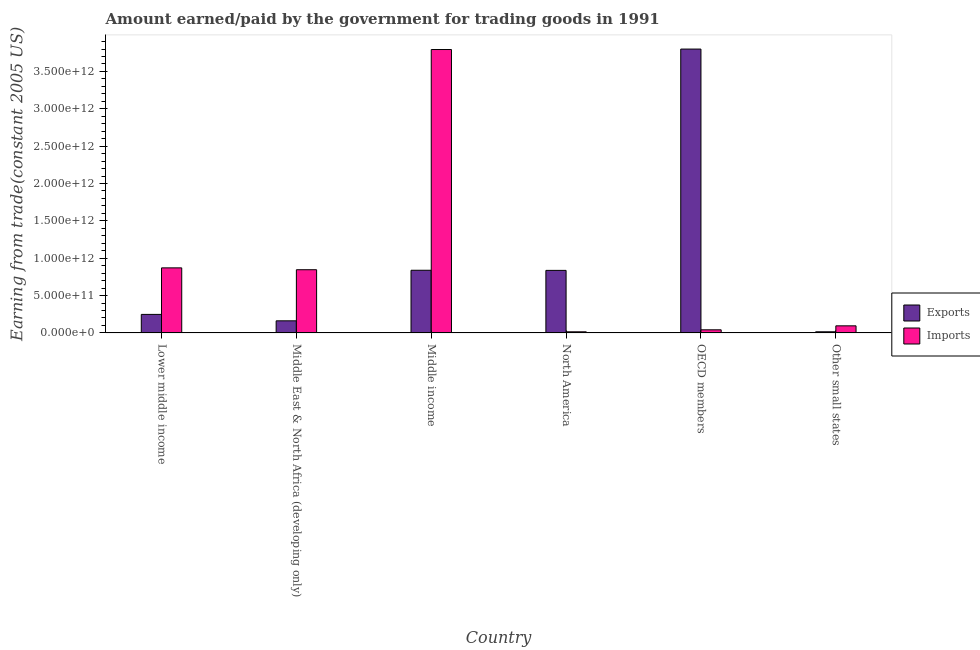How many different coloured bars are there?
Give a very brief answer. 2. Are the number of bars per tick equal to the number of legend labels?
Ensure brevity in your answer.  Yes. Are the number of bars on each tick of the X-axis equal?
Ensure brevity in your answer.  Yes. How many bars are there on the 6th tick from the right?
Offer a very short reply. 2. What is the label of the 1st group of bars from the left?
Ensure brevity in your answer.  Lower middle income. What is the amount earned from exports in Middle income?
Offer a very short reply. 8.39e+11. Across all countries, what is the maximum amount paid for imports?
Offer a very short reply. 3.79e+12. Across all countries, what is the minimum amount earned from exports?
Your answer should be compact. 1.55e+1. In which country was the amount earned from exports minimum?
Ensure brevity in your answer.  Other small states. What is the total amount earned from exports in the graph?
Offer a very short reply. 5.90e+12. What is the difference between the amount paid for imports in Middle East & North Africa (developing only) and that in Middle income?
Offer a terse response. -2.95e+12. What is the difference between the amount paid for imports in Lower middle income and the amount earned from exports in North America?
Ensure brevity in your answer.  3.37e+1. What is the average amount paid for imports per country?
Your answer should be very brief. 9.44e+11. What is the difference between the amount paid for imports and amount earned from exports in Middle East & North Africa (developing only)?
Your response must be concise. 6.84e+11. In how many countries, is the amount earned from exports greater than 2000000000000 US$?
Provide a succinct answer. 1. What is the ratio of the amount earned from exports in Lower middle income to that in Middle East & North Africa (developing only)?
Offer a terse response. 1.53. Is the amount paid for imports in OECD members less than that in Other small states?
Make the answer very short. Yes. Is the difference between the amount paid for imports in Middle East & North Africa (developing only) and OECD members greater than the difference between the amount earned from exports in Middle East & North Africa (developing only) and OECD members?
Your answer should be very brief. Yes. What is the difference between the highest and the second highest amount earned from exports?
Provide a short and direct response. 2.96e+12. What is the difference between the highest and the lowest amount earned from exports?
Your answer should be very brief. 3.78e+12. Is the sum of the amount paid for imports in North America and Other small states greater than the maximum amount earned from exports across all countries?
Your response must be concise. No. What does the 1st bar from the left in Middle East & North Africa (developing only) represents?
Give a very brief answer. Exports. What does the 1st bar from the right in Lower middle income represents?
Give a very brief answer. Imports. Are all the bars in the graph horizontal?
Give a very brief answer. No. What is the difference between two consecutive major ticks on the Y-axis?
Provide a succinct answer. 5.00e+11. Does the graph contain grids?
Provide a short and direct response. No. Where does the legend appear in the graph?
Provide a succinct answer. Center right. How are the legend labels stacked?
Offer a terse response. Vertical. What is the title of the graph?
Keep it short and to the point. Amount earned/paid by the government for trading goods in 1991. Does "Lower secondary rate" appear as one of the legend labels in the graph?
Give a very brief answer. No. What is the label or title of the Y-axis?
Keep it short and to the point. Earning from trade(constant 2005 US). What is the Earning from trade(constant 2005 US) of Exports in Lower middle income?
Offer a terse response. 2.48e+11. What is the Earning from trade(constant 2005 US) in Imports in Lower middle income?
Your answer should be very brief. 8.71e+11. What is the Earning from trade(constant 2005 US) of Exports in Middle East & North Africa (developing only)?
Your response must be concise. 1.62e+11. What is the Earning from trade(constant 2005 US) of Imports in Middle East & North Africa (developing only)?
Provide a succinct answer. 8.46e+11. What is the Earning from trade(constant 2005 US) of Exports in Middle income?
Offer a terse response. 8.39e+11. What is the Earning from trade(constant 2005 US) of Imports in Middle income?
Your answer should be compact. 3.79e+12. What is the Earning from trade(constant 2005 US) of Exports in North America?
Provide a succinct answer. 8.37e+11. What is the Earning from trade(constant 2005 US) in Imports in North America?
Offer a terse response. 1.52e+1. What is the Earning from trade(constant 2005 US) of Exports in OECD members?
Your response must be concise. 3.80e+12. What is the Earning from trade(constant 2005 US) of Imports in OECD members?
Your answer should be compact. 4.19e+1. What is the Earning from trade(constant 2005 US) in Exports in Other small states?
Provide a succinct answer. 1.55e+1. What is the Earning from trade(constant 2005 US) of Imports in Other small states?
Provide a succinct answer. 9.51e+1. Across all countries, what is the maximum Earning from trade(constant 2005 US) of Exports?
Make the answer very short. 3.80e+12. Across all countries, what is the maximum Earning from trade(constant 2005 US) in Imports?
Give a very brief answer. 3.79e+12. Across all countries, what is the minimum Earning from trade(constant 2005 US) in Exports?
Provide a succinct answer. 1.55e+1. Across all countries, what is the minimum Earning from trade(constant 2005 US) of Imports?
Your response must be concise. 1.52e+1. What is the total Earning from trade(constant 2005 US) in Exports in the graph?
Provide a succinct answer. 5.90e+12. What is the total Earning from trade(constant 2005 US) in Imports in the graph?
Provide a succinct answer. 5.66e+12. What is the difference between the Earning from trade(constant 2005 US) of Exports in Lower middle income and that in Middle East & North Africa (developing only)?
Ensure brevity in your answer.  8.59e+1. What is the difference between the Earning from trade(constant 2005 US) of Imports in Lower middle income and that in Middle East & North Africa (developing only)?
Offer a terse response. 2.50e+1. What is the difference between the Earning from trade(constant 2005 US) in Exports in Lower middle income and that in Middle income?
Your response must be concise. -5.91e+11. What is the difference between the Earning from trade(constant 2005 US) in Imports in Lower middle income and that in Middle income?
Provide a short and direct response. -2.92e+12. What is the difference between the Earning from trade(constant 2005 US) in Exports in Lower middle income and that in North America?
Offer a very short reply. -5.89e+11. What is the difference between the Earning from trade(constant 2005 US) in Imports in Lower middle income and that in North America?
Make the answer very short. 8.56e+11. What is the difference between the Earning from trade(constant 2005 US) of Exports in Lower middle income and that in OECD members?
Make the answer very short. -3.55e+12. What is the difference between the Earning from trade(constant 2005 US) in Imports in Lower middle income and that in OECD members?
Provide a succinct answer. 8.29e+11. What is the difference between the Earning from trade(constant 2005 US) of Exports in Lower middle income and that in Other small states?
Offer a very short reply. 2.33e+11. What is the difference between the Earning from trade(constant 2005 US) of Imports in Lower middle income and that in Other small states?
Make the answer very short. 7.76e+11. What is the difference between the Earning from trade(constant 2005 US) in Exports in Middle East & North Africa (developing only) and that in Middle income?
Provide a succinct answer. -6.77e+11. What is the difference between the Earning from trade(constant 2005 US) of Imports in Middle East & North Africa (developing only) and that in Middle income?
Offer a very short reply. -2.95e+12. What is the difference between the Earning from trade(constant 2005 US) of Exports in Middle East & North Africa (developing only) and that in North America?
Give a very brief answer. -6.75e+11. What is the difference between the Earning from trade(constant 2005 US) in Imports in Middle East & North Africa (developing only) and that in North America?
Offer a terse response. 8.31e+11. What is the difference between the Earning from trade(constant 2005 US) in Exports in Middle East & North Africa (developing only) and that in OECD members?
Offer a terse response. -3.64e+12. What is the difference between the Earning from trade(constant 2005 US) in Imports in Middle East & North Africa (developing only) and that in OECD members?
Your answer should be compact. 8.04e+11. What is the difference between the Earning from trade(constant 2005 US) in Exports in Middle East & North Africa (developing only) and that in Other small states?
Provide a short and direct response. 1.47e+11. What is the difference between the Earning from trade(constant 2005 US) of Imports in Middle East & North Africa (developing only) and that in Other small states?
Your answer should be very brief. 7.51e+11. What is the difference between the Earning from trade(constant 2005 US) in Exports in Middle income and that in North America?
Your answer should be compact. 1.74e+09. What is the difference between the Earning from trade(constant 2005 US) in Imports in Middle income and that in North America?
Offer a terse response. 3.78e+12. What is the difference between the Earning from trade(constant 2005 US) of Exports in Middle income and that in OECD members?
Provide a short and direct response. -2.96e+12. What is the difference between the Earning from trade(constant 2005 US) in Imports in Middle income and that in OECD members?
Ensure brevity in your answer.  3.75e+12. What is the difference between the Earning from trade(constant 2005 US) in Exports in Middle income and that in Other small states?
Keep it short and to the point. 8.24e+11. What is the difference between the Earning from trade(constant 2005 US) of Imports in Middle income and that in Other small states?
Provide a succinct answer. 3.70e+12. What is the difference between the Earning from trade(constant 2005 US) in Exports in North America and that in OECD members?
Your response must be concise. -2.96e+12. What is the difference between the Earning from trade(constant 2005 US) in Imports in North America and that in OECD members?
Keep it short and to the point. -2.67e+1. What is the difference between the Earning from trade(constant 2005 US) in Exports in North America and that in Other small states?
Your answer should be very brief. 8.22e+11. What is the difference between the Earning from trade(constant 2005 US) of Imports in North America and that in Other small states?
Give a very brief answer. -7.99e+1. What is the difference between the Earning from trade(constant 2005 US) in Exports in OECD members and that in Other small states?
Give a very brief answer. 3.78e+12. What is the difference between the Earning from trade(constant 2005 US) of Imports in OECD members and that in Other small states?
Keep it short and to the point. -5.32e+1. What is the difference between the Earning from trade(constant 2005 US) of Exports in Lower middle income and the Earning from trade(constant 2005 US) of Imports in Middle East & North Africa (developing only)?
Provide a succinct answer. -5.98e+11. What is the difference between the Earning from trade(constant 2005 US) in Exports in Lower middle income and the Earning from trade(constant 2005 US) in Imports in Middle income?
Provide a short and direct response. -3.55e+12. What is the difference between the Earning from trade(constant 2005 US) in Exports in Lower middle income and the Earning from trade(constant 2005 US) in Imports in North America?
Provide a succinct answer. 2.33e+11. What is the difference between the Earning from trade(constant 2005 US) in Exports in Lower middle income and the Earning from trade(constant 2005 US) in Imports in OECD members?
Your answer should be very brief. 2.06e+11. What is the difference between the Earning from trade(constant 2005 US) in Exports in Lower middle income and the Earning from trade(constant 2005 US) in Imports in Other small states?
Provide a short and direct response. 1.53e+11. What is the difference between the Earning from trade(constant 2005 US) in Exports in Middle East & North Africa (developing only) and the Earning from trade(constant 2005 US) in Imports in Middle income?
Make the answer very short. -3.63e+12. What is the difference between the Earning from trade(constant 2005 US) of Exports in Middle East & North Africa (developing only) and the Earning from trade(constant 2005 US) of Imports in North America?
Your answer should be very brief. 1.47e+11. What is the difference between the Earning from trade(constant 2005 US) in Exports in Middle East & North Africa (developing only) and the Earning from trade(constant 2005 US) in Imports in OECD members?
Offer a very short reply. 1.20e+11. What is the difference between the Earning from trade(constant 2005 US) in Exports in Middle East & North Africa (developing only) and the Earning from trade(constant 2005 US) in Imports in Other small states?
Provide a succinct answer. 6.71e+1. What is the difference between the Earning from trade(constant 2005 US) of Exports in Middle income and the Earning from trade(constant 2005 US) of Imports in North America?
Provide a short and direct response. 8.24e+11. What is the difference between the Earning from trade(constant 2005 US) of Exports in Middle income and the Earning from trade(constant 2005 US) of Imports in OECD members?
Make the answer very short. 7.97e+11. What is the difference between the Earning from trade(constant 2005 US) in Exports in Middle income and the Earning from trade(constant 2005 US) in Imports in Other small states?
Provide a succinct answer. 7.44e+11. What is the difference between the Earning from trade(constant 2005 US) in Exports in North America and the Earning from trade(constant 2005 US) in Imports in OECD members?
Give a very brief answer. 7.95e+11. What is the difference between the Earning from trade(constant 2005 US) of Exports in North America and the Earning from trade(constant 2005 US) of Imports in Other small states?
Make the answer very short. 7.42e+11. What is the difference between the Earning from trade(constant 2005 US) of Exports in OECD members and the Earning from trade(constant 2005 US) of Imports in Other small states?
Provide a short and direct response. 3.70e+12. What is the average Earning from trade(constant 2005 US) of Exports per country?
Your answer should be very brief. 9.84e+11. What is the average Earning from trade(constant 2005 US) in Imports per country?
Your response must be concise. 9.44e+11. What is the difference between the Earning from trade(constant 2005 US) of Exports and Earning from trade(constant 2005 US) of Imports in Lower middle income?
Give a very brief answer. -6.23e+11. What is the difference between the Earning from trade(constant 2005 US) of Exports and Earning from trade(constant 2005 US) of Imports in Middle East & North Africa (developing only)?
Give a very brief answer. -6.84e+11. What is the difference between the Earning from trade(constant 2005 US) in Exports and Earning from trade(constant 2005 US) in Imports in Middle income?
Give a very brief answer. -2.95e+12. What is the difference between the Earning from trade(constant 2005 US) of Exports and Earning from trade(constant 2005 US) of Imports in North America?
Your response must be concise. 8.22e+11. What is the difference between the Earning from trade(constant 2005 US) of Exports and Earning from trade(constant 2005 US) of Imports in OECD members?
Give a very brief answer. 3.76e+12. What is the difference between the Earning from trade(constant 2005 US) of Exports and Earning from trade(constant 2005 US) of Imports in Other small states?
Offer a terse response. -7.96e+1. What is the ratio of the Earning from trade(constant 2005 US) of Exports in Lower middle income to that in Middle East & North Africa (developing only)?
Your answer should be very brief. 1.53. What is the ratio of the Earning from trade(constant 2005 US) of Imports in Lower middle income to that in Middle East & North Africa (developing only)?
Make the answer very short. 1.03. What is the ratio of the Earning from trade(constant 2005 US) of Exports in Lower middle income to that in Middle income?
Offer a terse response. 0.3. What is the ratio of the Earning from trade(constant 2005 US) of Imports in Lower middle income to that in Middle income?
Ensure brevity in your answer.  0.23. What is the ratio of the Earning from trade(constant 2005 US) of Exports in Lower middle income to that in North America?
Your answer should be compact. 0.3. What is the ratio of the Earning from trade(constant 2005 US) of Imports in Lower middle income to that in North America?
Keep it short and to the point. 57.39. What is the ratio of the Earning from trade(constant 2005 US) in Exports in Lower middle income to that in OECD members?
Your response must be concise. 0.07. What is the ratio of the Earning from trade(constant 2005 US) in Imports in Lower middle income to that in OECD members?
Offer a very short reply. 20.8. What is the ratio of the Earning from trade(constant 2005 US) of Exports in Lower middle income to that in Other small states?
Ensure brevity in your answer.  16.03. What is the ratio of the Earning from trade(constant 2005 US) of Imports in Lower middle income to that in Other small states?
Make the answer very short. 9.16. What is the ratio of the Earning from trade(constant 2005 US) of Exports in Middle East & North Africa (developing only) to that in Middle income?
Offer a terse response. 0.19. What is the ratio of the Earning from trade(constant 2005 US) of Imports in Middle East & North Africa (developing only) to that in Middle income?
Give a very brief answer. 0.22. What is the ratio of the Earning from trade(constant 2005 US) in Exports in Middle East & North Africa (developing only) to that in North America?
Provide a short and direct response. 0.19. What is the ratio of the Earning from trade(constant 2005 US) of Imports in Middle East & North Africa (developing only) to that in North America?
Provide a succinct answer. 55.74. What is the ratio of the Earning from trade(constant 2005 US) in Exports in Middle East & North Africa (developing only) to that in OECD members?
Make the answer very short. 0.04. What is the ratio of the Earning from trade(constant 2005 US) in Imports in Middle East & North Africa (developing only) to that in OECD members?
Provide a succinct answer. 20.21. What is the ratio of the Earning from trade(constant 2005 US) in Exports in Middle East & North Africa (developing only) to that in Other small states?
Make the answer very short. 10.48. What is the ratio of the Earning from trade(constant 2005 US) of Imports in Middle East & North Africa (developing only) to that in Other small states?
Your answer should be compact. 8.9. What is the ratio of the Earning from trade(constant 2005 US) of Imports in Middle income to that in North America?
Offer a terse response. 249.92. What is the ratio of the Earning from trade(constant 2005 US) in Exports in Middle income to that in OECD members?
Your response must be concise. 0.22. What is the ratio of the Earning from trade(constant 2005 US) of Imports in Middle income to that in OECD members?
Keep it short and to the point. 90.61. What is the ratio of the Earning from trade(constant 2005 US) in Exports in Middle income to that in Other small states?
Provide a succinct answer. 54.23. What is the ratio of the Earning from trade(constant 2005 US) of Imports in Middle income to that in Other small states?
Your answer should be very brief. 39.89. What is the ratio of the Earning from trade(constant 2005 US) in Exports in North America to that in OECD members?
Your response must be concise. 0.22. What is the ratio of the Earning from trade(constant 2005 US) in Imports in North America to that in OECD members?
Offer a terse response. 0.36. What is the ratio of the Earning from trade(constant 2005 US) of Exports in North America to that in Other small states?
Give a very brief answer. 54.12. What is the ratio of the Earning from trade(constant 2005 US) in Imports in North America to that in Other small states?
Your answer should be compact. 0.16. What is the ratio of the Earning from trade(constant 2005 US) in Exports in OECD members to that in Other small states?
Provide a short and direct response. 245.57. What is the ratio of the Earning from trade(constant 2005 US) in Imports in OECD members to that in Other small states?
Make the answer very short. 0.44. What is the difference between the highest and the second highest Earning from trade(constant 2005 US) in Exports?
Give a very brief answer. 2.96e+12. What is the difference between the highest and the second highest Earning from trade(constant 2005 US) of Imports?
Make the answer very short. 2.92e+12. What is the difference between the highest and the lowest Earning from trade(constant 2005 US) of Exports?
Keep it short and to the point. 3.78e+12. What is the difference between the highest and the lowest Earning from trade(constant 2005 US) of Imports?
Offer a terse response. 3.78e+12. 